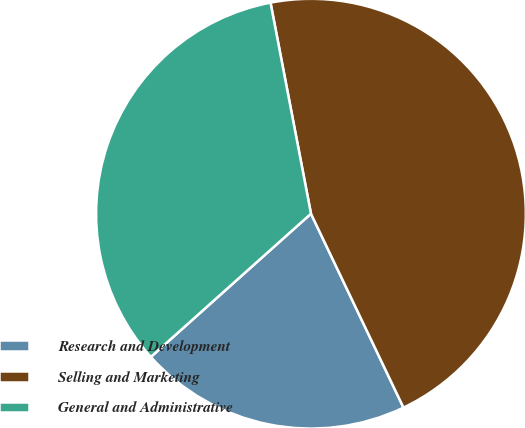Convert chart. <chart><loc_0><loc_0><loc_500><loc_500><pie_chart><fcel>Research and Development<fcel>Selling and Marketing<fcel>General and Administrative<nl><fcel>20.47%<fcel>45.93%<fcel>33.6%<nl></chart> 